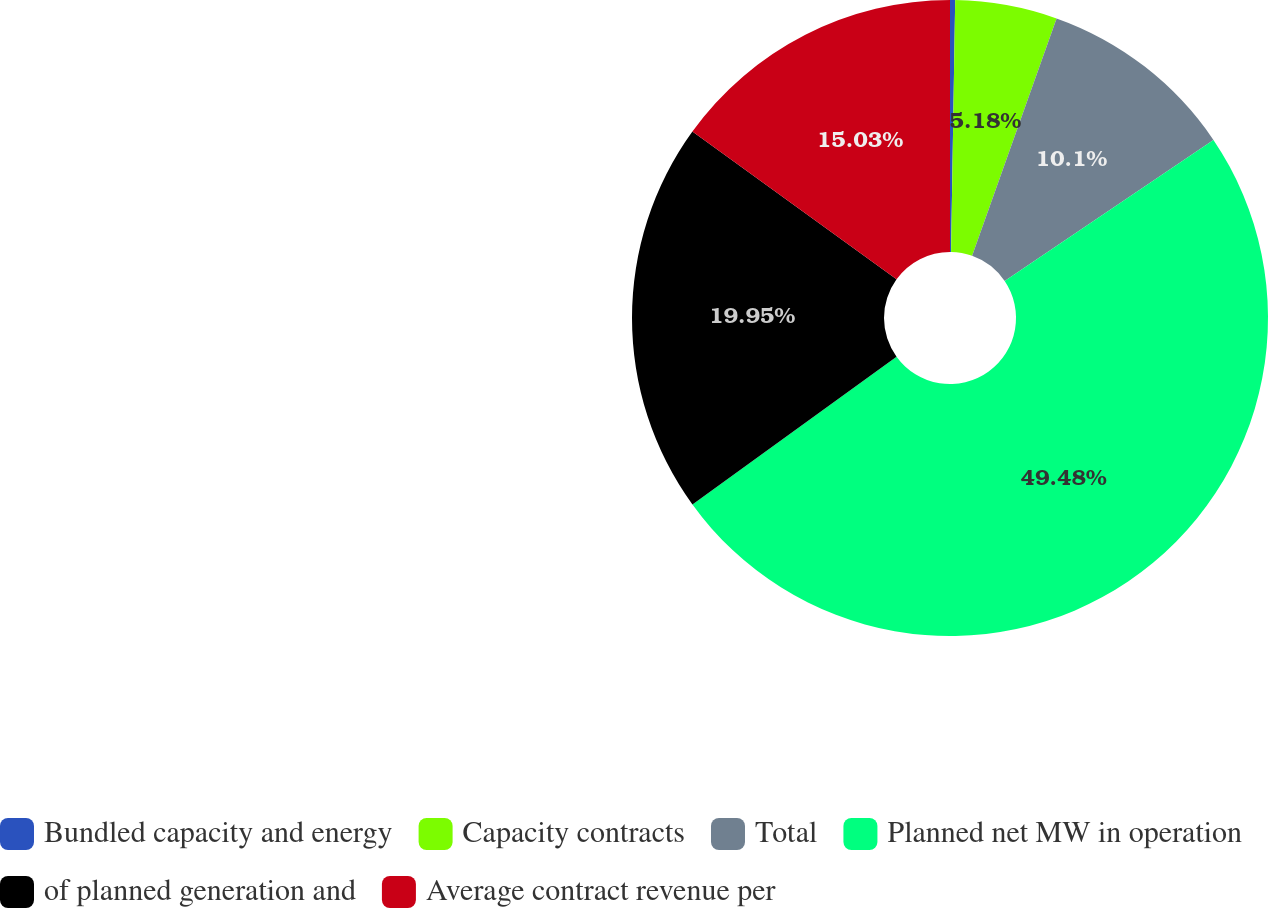Convert chart. <chart><loc_0><loc_0><loc_500><loc_500><pie_chart><fcel>Bundled capacity and energy<fcel>Capacity contracts<fcel>Total<fcel>Planned net MW in operation<fcel>of planned generation and<fcel>Average contract revenue per<nl><fcel>0.26%<fcel>5.18%<fcel>10.1%<fcel>49.49%<fcel>19.95%<fcel>15.03%<nl></chart> 